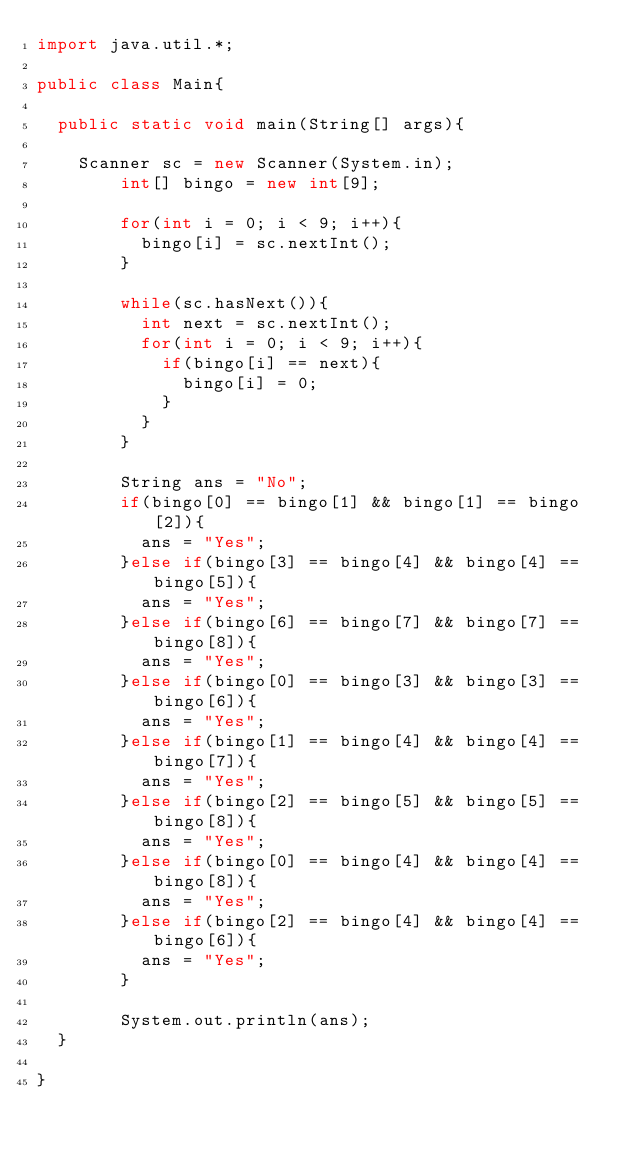<code> <loc_0><loc_0><loc_500><loc_500><_Java_>import java.util.*;

public class Main{

	public static void main(String[] args){

		Scanner sc = new Scanner(System.in);
        int[] bingo = new int[9];
      
        for(int i = 0; i < 9; i++){
          bingo[i] = sc.nextInt();
        }
      
        while(sc.hasNext()){
          int next = sc.nextInt();
          for(int i = 0; i < 9; i++){
            if(bingo[i] == next){
              bingo[i] = 0;
            }
          }
        }
       
        String ans = "No";
        if(bingo[0] == bingo[1] && bingo[1] == bingo[2]){
          ans = "Yes";
        }else if(bingo[3] == bingo[4] && bingo[4] == bingo[5]){
          ans = "Yes";
        }else if(bingo[6] == bingo[7] && bingo[7] == bingo[8]){
          ans = "Yes";
        }else if(bingo[0] == bingo[3] && bingo[3] == bingo[6]){
          ans = "Yes";
        }else if(bingo[1] == bingo[4] && bingo[4] == bingo[7]){
          ans = "Yes";
        }else if(bingo[2] == bingo[5] && bingo[5] == bingo[8]){
          ans = "Yes";
        }else if(bingo[0] == bingo[4] && bingo[4] == bingo[8]){
          ans = "Yes";
        }else if(bingo[2] == bingo[4] && bingo[4] == bingo[6]){
          ans = "Yes";
        }
        
        System.out.println(ans);
	}

}</code> 